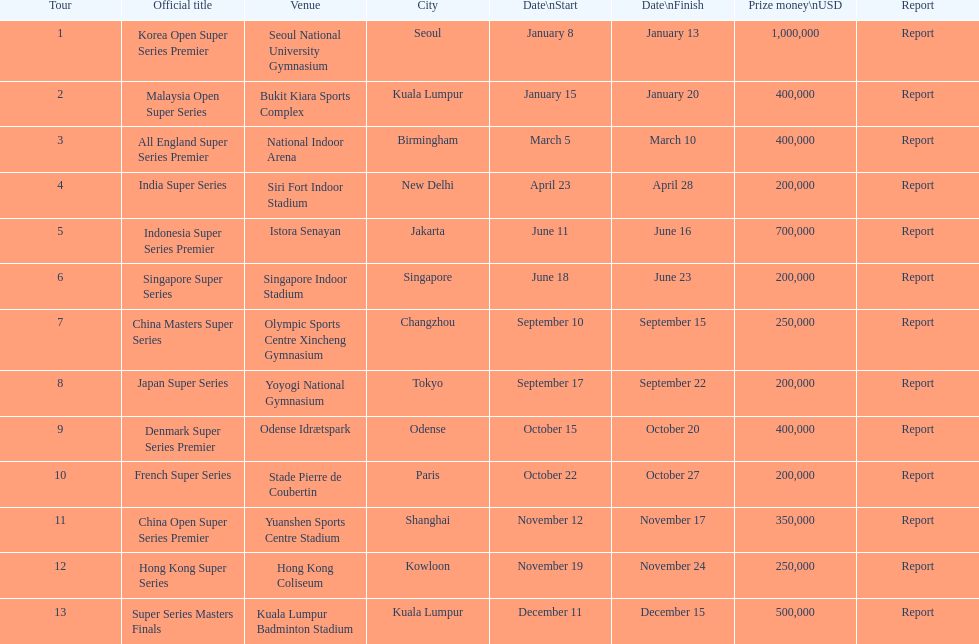How many days does the japan super series last? 5. Could you parse the entire table as a dict? {'header': ['Tour', 'Official title', 'Venue', 'City', 'Date\\nStart', 'Date\\nFinish', 'Prize money\\nUSD', 'Report'], 'rows': [['1', 'Korea Open Super Series Premier', 'Seoul National University Gymnasium', 'Seoul', 'January 8', 'January 13', '1,000,000', 'Report'], ['2', 'Malaysia Open Super Series', 'Bukit Kiara Sports Complex', 'Kuala Lumpur', 'January 15', 'January 20', '400,000', 'Report'], ['3', 'All England Super Series Premier', 'National Indoor Arena', 'Birmingham', 'March 5', 'March 10', '400,000', 'Report'], ['4', 'India Super Series', 'Siri Fort Indoor Stadium', 'New Delhi', 'April 23', 'April 28', '200,000', 'Report'], ['5', 'Indonesia Super Series Premier', 'Istora Senayan', 'Jakarta', 'June 11', 'June 16', '700,000', 'Report'], ['6', 'Singapore Super Series', 'Singapore Indoor Stadium', 'Singapore', 'June 18', 'June 23', '200,000', 'Report'], ['7', 'China Masters Super Series', 'Olympic Sports Centre Xincheng Gymnasium', 'Changzhou', 'September 10', 'September 15', '250,000', 'Report'], ['8', 'Japan Super Series', 'Yoyogi National Gymnasium', 'Tokyo', 'September 17', 'September 22', '200,000', 'Report'], ['9', 'Denmark Super Series Premier', 'Odense Idrætspark', 'Odense', 'October 15', 'October 20', '400,000', 'Report'], ['10', 'French Super Series', 'Stade Pierre de Coubertin', 'Paris', 'October 22', 'October 27', '200,000', 'Report'], ['11', 'China Open Super Series Premier', 'Yuanshen Sports Centre Stadium', 'Shanghai', 'November 12', 'November 17', '350,000', 'Report'], ['12', 'Hong Kong Super Series', 'Hong Kong Coliseum', 'Kowloon', 'November 19', 'November 24', '250,000', 'Report'], ['13', 'Super Series Masters Finals', 'Kuala Lumpur Badminton Stadium', 'Kuala Lumpur', 'December 11', 'December 15', '500,000', 'Report']]} 